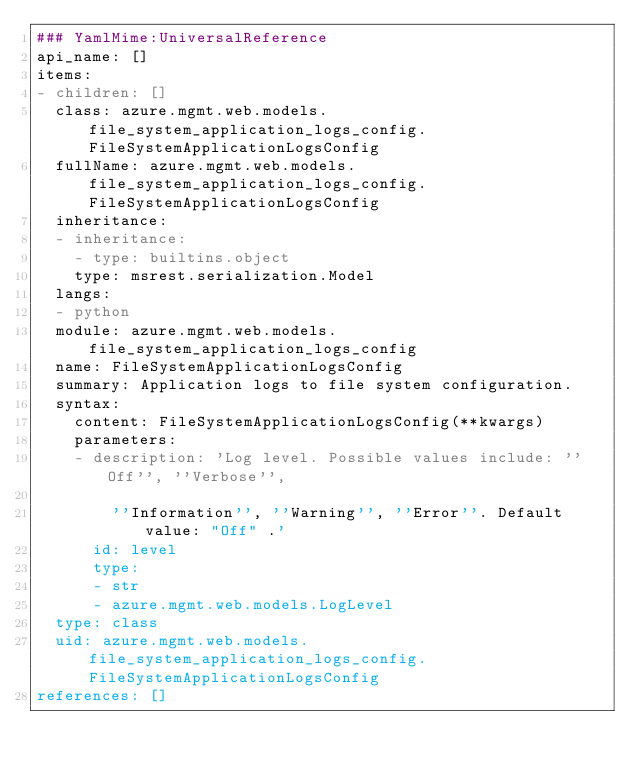<code> <loc_0><loc_0><loc_500><loc_500><_YAML_>### YamlMime:UniversalReference
api_name: []
items:
- children: []
  class: azure.mgmt.web.models.file_system_application_logs_config.FileSystemApplicationLogsConfig
  fullName: azure.mgmt.web.models.file_system_application_logs_config.FileSystemApplicationLogsConfig
  inheritance:
  - inheritance:
    - type: builtins.object
    type: msrest.serialization.Model
  langs:
  - python
  module: azure.mgmt.web.models.file_system_application_logs_config
  name: FileSystemApplicationLogsConfig
  summary: Application logs to file system configuration.
  syntax:
    content: FileSystemApplicationLogsConfig(**kwargs)
    parameters:
    - description: 'Log level. Possible values include: ''Off'', ''Verbose'',

        ''Information'', ''Warning'', ''Error''. Default value: "Off" .'
      id: level
      type:
      - str
      - azure.mgmt.web.models.LogLevel
  type: class
  uid: azure.mgmt.web.models.file_system_application_logs_config.FileSystemApplicationLogsConfig
references: []
</code> 